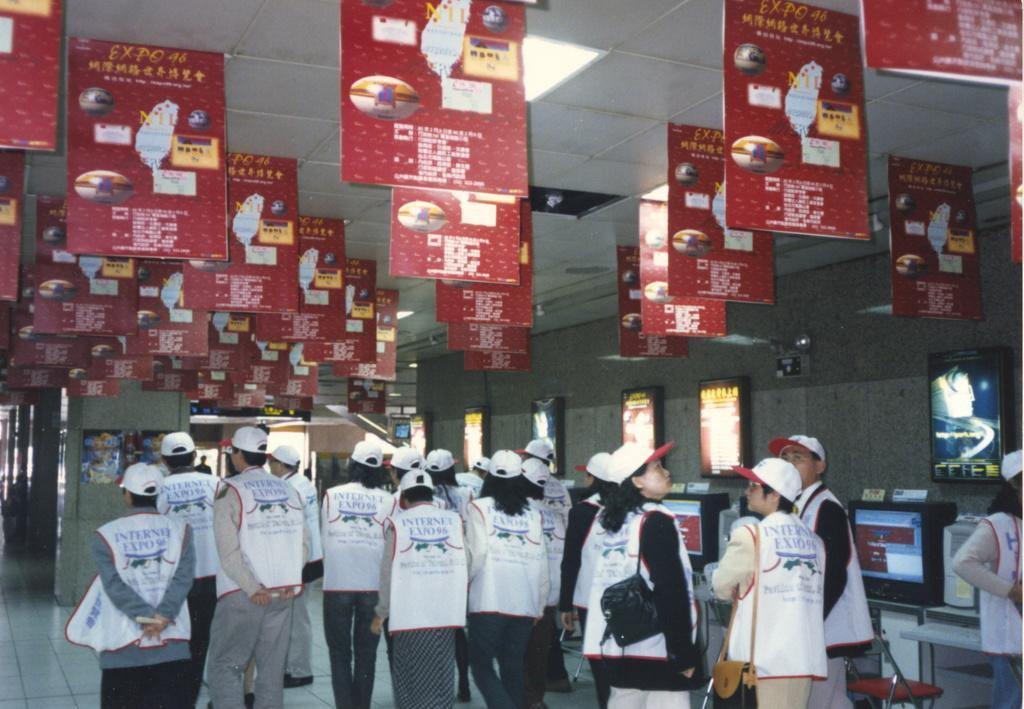Describe this image in one or two sentences. In this image we can see few persons are standing on the floor and among them few persons are carrying bags on the shoulders and all of them have caps on their heads. We can see hoardings, lights on the ceiling, boards on the wall, objects, posters on the pillar, monitors, keyboard and CPU. 